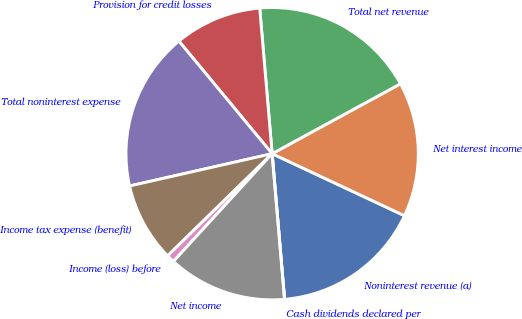Convert chart to OTSL. <chart><loc_0><loc_0><loc_500><loc_500><pie_chart><fcel>Noninterest revenue (a)<fcel>Net interest income<fcel>Total net revenue<fcel>Provision for credit losses<fcel>Total noninterest expense<fcel>Income tax expense (benefit)<fcel>Income (loss) before<fcel>Net income<fcel>Cash dividends declared per<nl><fcel>16.67%<fcel>14.91%<fcel>18.42%<fcel>9.65%<fcel>17.54%<fcel>8.77%<fcel>0.88%<fcel>13.16%<fcel>0.0%<nl></chart> 